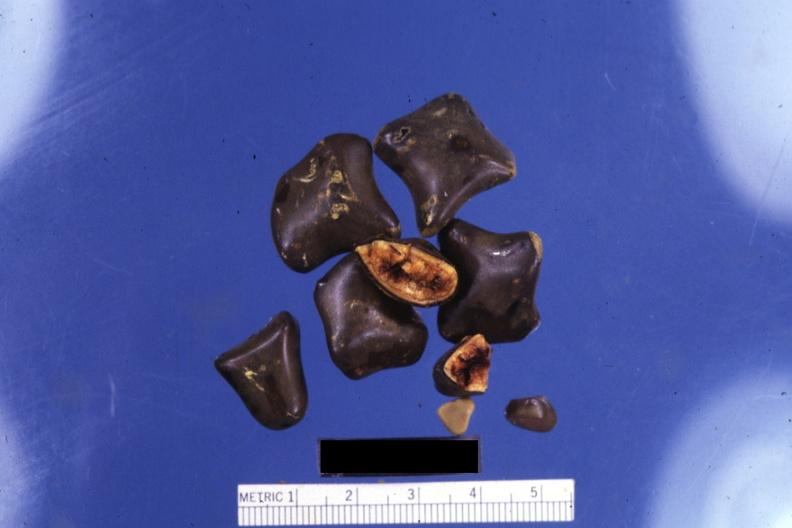s pagets disease showing cut surfaces?
Answer the question using a single word or phrase. No 